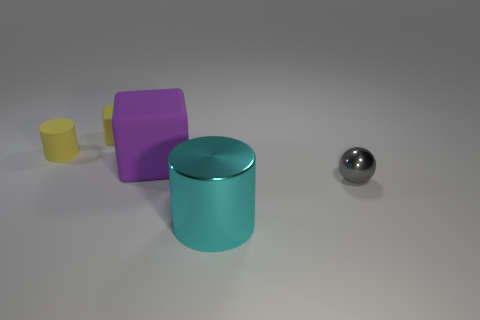Add 4 large green rubber cubes. How many objects exist? 9 Subtract all cylinders. How many objects are left? 3 Add 3 cyan cylinders. How many cyan cylinders exist? 4 Subtract 0 green balls. How many objects are left? 5 Subtract all purple cubes. Subtract all spheres. How many objects are left? 3 Add 3 rubber blocks. How many rubber blocks are left? 5 